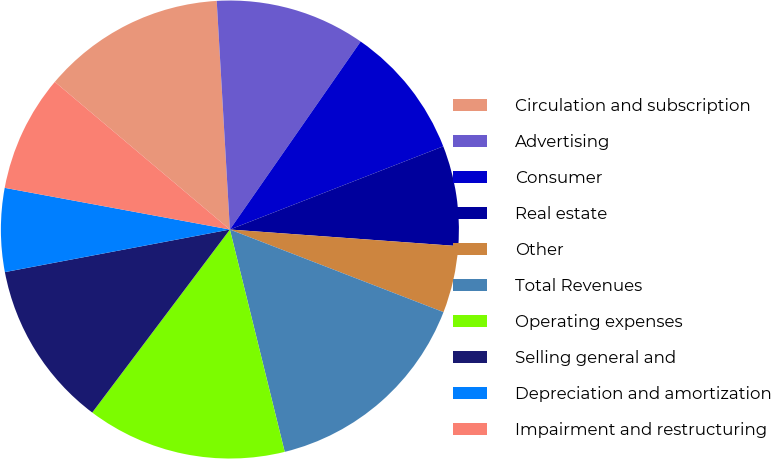<chart> <loc_0><loc_0><loc_500><loc_500><pie_chart><fcel>Circulation and subscription<fcel>Advertising<fcel>Consumer<fcel>Real estate<fcel>Other<fcel>Total Revenues<fcel>Operating expenses<fcel>Selling general and<fcel>Depreciation and amortization<fcel>Impairment and restructuring<nl><fcel>12.93%<fcel>10.59%<fcel>9.41%<fcel>7.07%<fcel>4.72%<fcel>15.28%<fcel>14.11%<fcel>11.76%<fcel>5.89%<fcel>8.24%<nl></chart> 